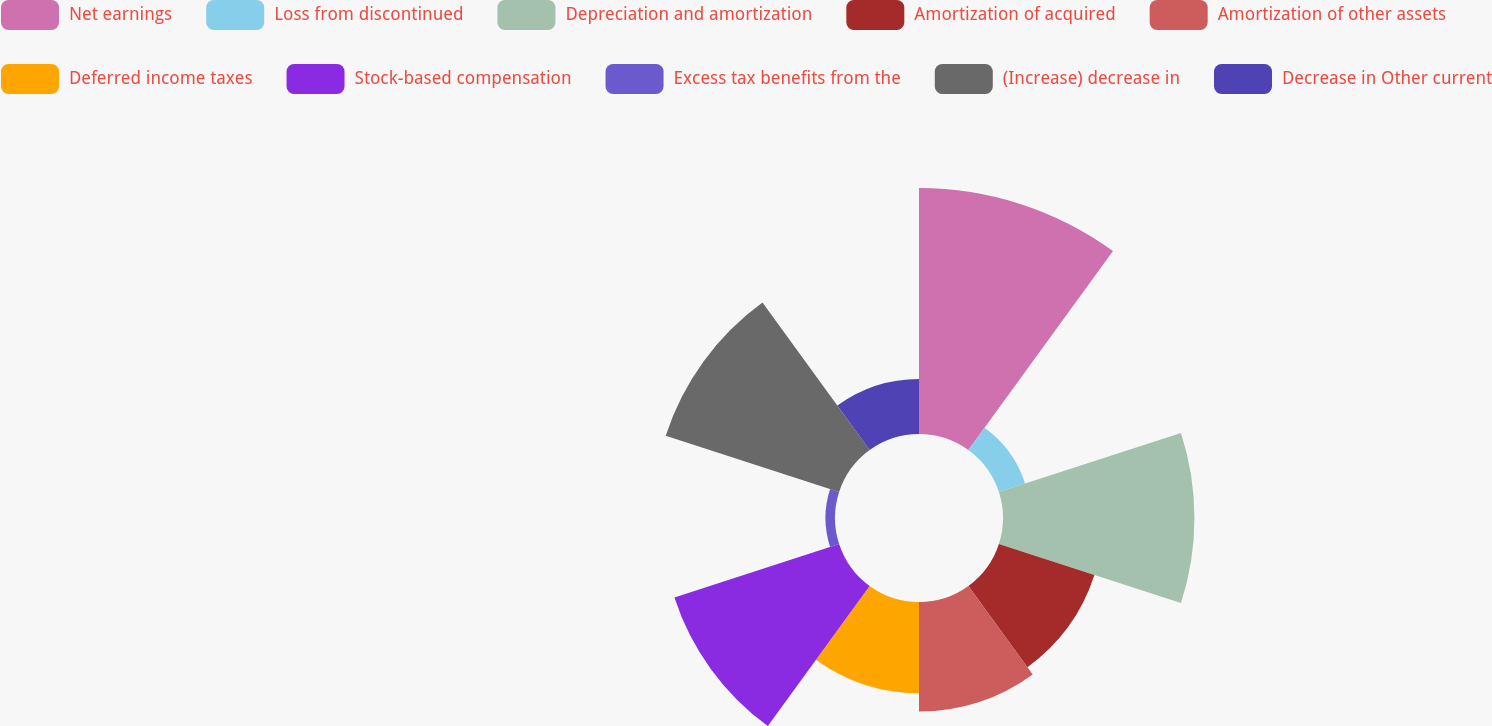Convert chart to OTSL. <chart><loc_0><loc_0><loc_500><loc_500><pie_chart><fcel>Net earnings<fcel>Loss from discontinued<fcel>Depreciation and amortization<fcel>Amortization of acquired<fcel>Amortization of other assets<fcel>Deferred income taxes<fcel>Stock-based compensation<fcel>Excess tax benefits from the<fcel>(Increase) decrease in<fcel>Decrease in Other current<nl><fcel>20.74%<fcel>2.33%<fcel>16.14%<fcel>8.47%<fcel>9.23%<fcel>7.7%<fcel>14.6%<fcel>0.8%<fcel>15.37%<fcel>4.63%<nl></chart> 